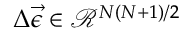<formula> <loc_0><loc_0><loc_500><loc_500>\Delta \vec { \epsilon } \in \mathcal { R } ^ { N ( N + 1 ) / 2 }</formula> 